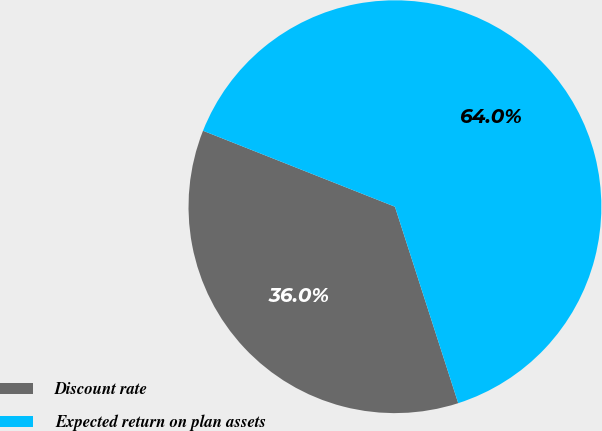<chart> <loc_0><loc_0><loc_500><loc_500><pie_chart><fcel>Discount rate<fcel>Expected return on plan assets<nl><fcel>35.96%<fcel>64.04%<nl></chart> 